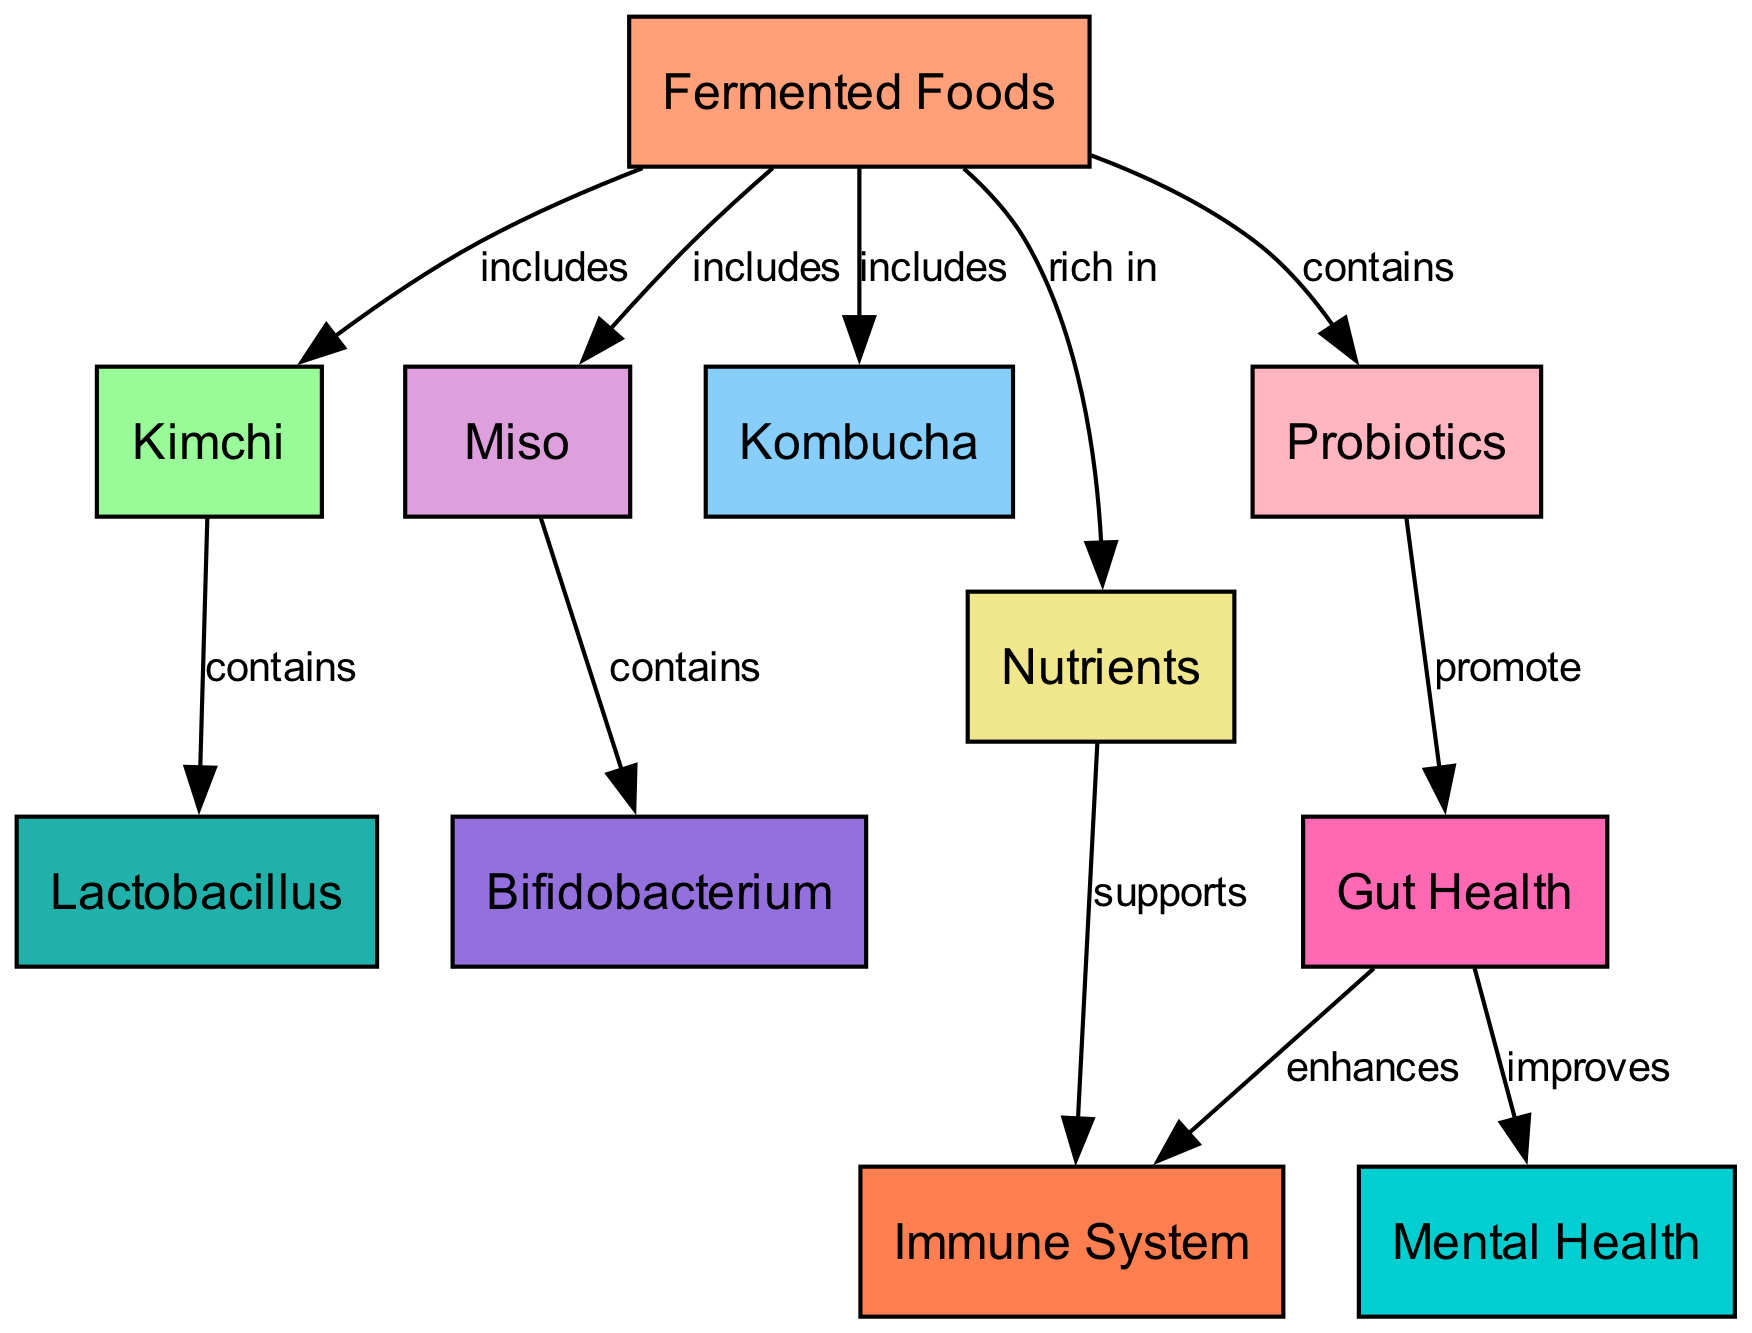What type of fermented food is kimchi? Kimchi is categorized as a fermented food in the diagram, directly indicated with a connection labeled "includes" from the "fermented foods" node to the "kimchi" node.
Answer: Fermented Food Which microorganisms are contained in miso? The diagram shows that miso contains bifidobacterium, as indicated by the direct connection labeled "contains" from the "miso" node to the "bifidobacterium" node.
Answer: Bifidobacterium How many edges are there in the diagram? By counting the connections between nodes, the total number of edges can be identified. The diagram lists 10 edges connecting various nodes and showing relationships.
Answer: 10 What health benefits do probiotics promote according to the diagram? The diagram illustrates that probiotics promote gut health, indicated by the connection labeled "promote" leading from the "probiotics" node to the "gut health" node.
Answer: Gut Health What is the relationship between gut health and mental health? The diagram shows that gut health improves mental health through a connection labeled "improves" between the "gut health" node and the "mental health" node, establishing a direct link of positive impact.
Answer: Improves What nutrients do fermented foods support? The diagram links nutrients to the immune system, labeled "supports," indicating that the nutrients present in fermented foods directly have a supportive role on the immune system.
Answer: Immune System How do probiotics affect gut health? Probiotics are shown to promote gut health in the diagram, as evidenced by the connection labeled "promote" from the "probiotics" node to the "gut health" node, emphasizing their beneficial effect.
Answer: Promote Which fermented food contains lactobacillus? The diagram specifies that kimchi contains lactobacillus, highlighted by the link labeled "contains" between the "kimchi" node and the "lactobacillus" node.
Answer: Lactobacillus What is the primary benefit of gut health as depicted in the diagram? The diagram demonstrates that gut health enhances the immune system, shown by the connection labeled "enhances" between the "gut health" node and the "immune system" node.
Answer: Enhances 